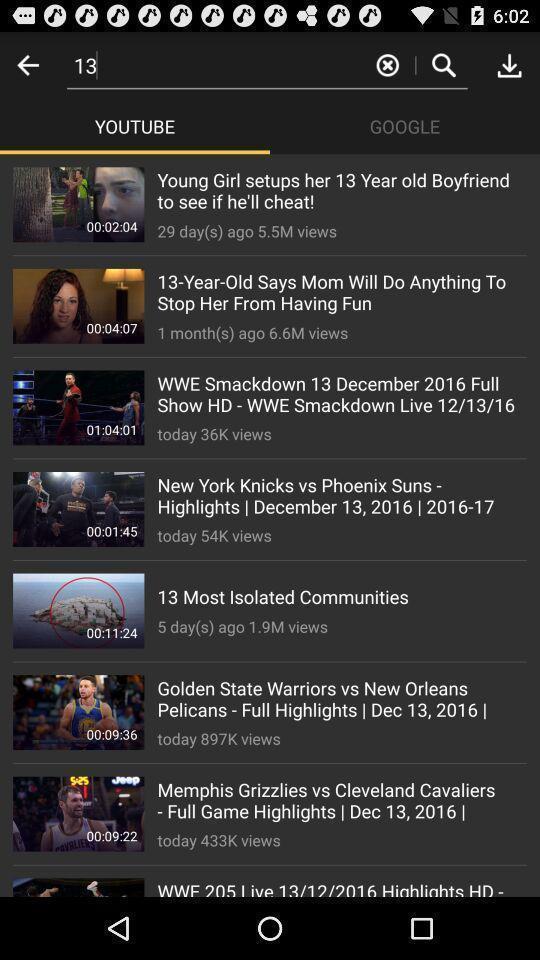Provide a description of this screenshot. Screen showing videos. 